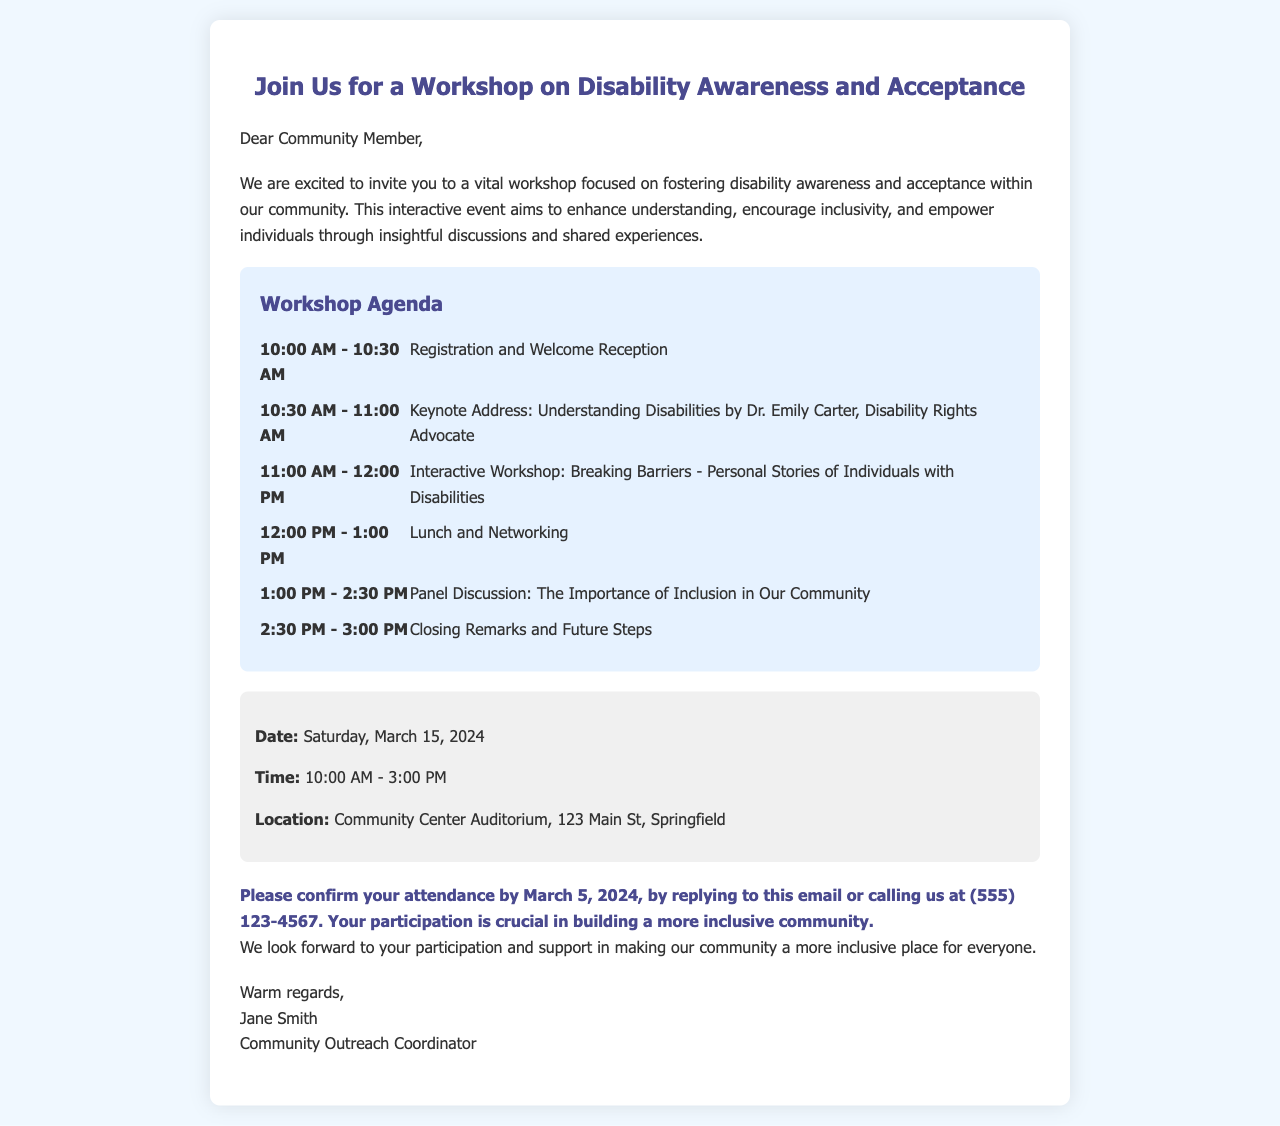What is the date of the workshop? The date is explicitly mentioned in the document as Saturday, March 15, 2024.
Answer: Saturday, March 15, 2024 Who is the keynote speaker? The document states that Dr. Emily Carter is the keynote speaker, along with her title.
Answer: Dr. Emily Carter What time does the workshop start? The starting time for the workshop is provided in the details section as 10:00 AM.
Answer: 10:00 AM What is the location of the workshop? The location is detailed in the document as Community Center Auditorium, 123 Main St, Springfield.
Answer: Community Center Auditorium, 123 Main St, Springfield How long is the panel discussion scheduled for? By examining the agenda, the panel discussion is scheduled for 1 hour and 30 minutes, from 1:00 PM to 2:30 PM.
Answer: 1 hour and 30 minutes What is required to confirm attendance? The document specifies that attendees need to confirm by replying to the email or calling, which is an explicit requirement.
Answer: Replying to this email or calling What time does the workshop end? The end time of the workshop is mentioned as 3:00 PM in the details section.
Answer: 3:00 PM What is the primary purpose of the workshop? The introduction details the workshop's aim to foster disability awareness and acceptance in the community.
Answer: Foster disability awareness and acceptance When is the RSVP deadline? The document states that RSVPs should be confirmed by March 5, 2024.
Answer: March 5, 2024 